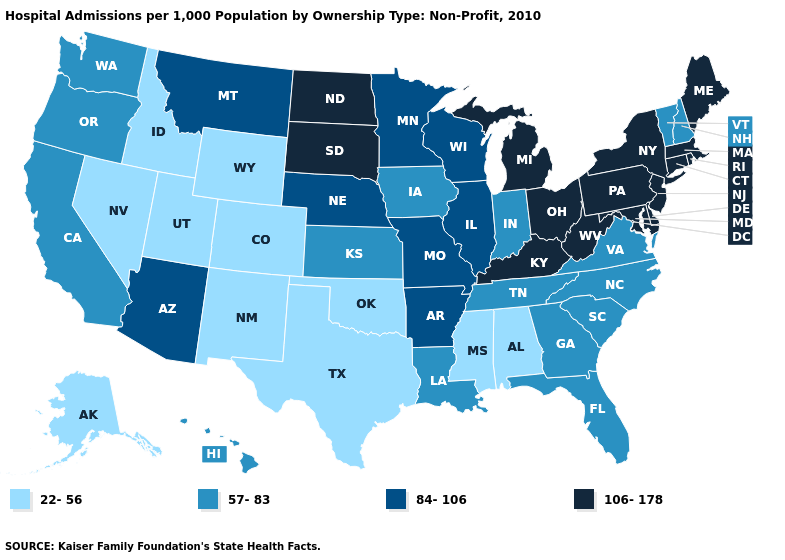Is the legend a continuous bar?
Answer briefly. No. Among the states that border Iowa , does Wisconsin have the highest value?
Give a very brief answer. No. Name the states that have a value in the range 22-56?
Keep it brief. Alabama, Alaska, Colorado, Idaho, Mississippi, Nevada, New Mexico, Oklahoma, Texas, Utah, Wyoming. Does the map have missing data?
Short answer required. No. Which states hav the highest value in the South?
Quick response, please. Delaware, Kentucky, Maryland, West Virginia. What is the highest value in the USA?
Give a very brief answer. 106-178. Among the states that border Indiana , which have the lowest value?
Answer briefly. Illinois. What is the lowest value in the South?
Concise answer only. 22-56. Name the states that have a value in the range 57-83?
Answer briefly. California, Florida, Georgia, Hawaii, Indiana, Iowa, Kansas, Louisiana, New Hampshire, North Carolina, Oregon, South Carolina, Tennessee, Vermont, Virginia, Washington. Among the states that border Oregon , which have the lowest value?
Concise answer only. Idaho, Nevada. Name the states that have a value in the range 22-56?
Answer briefly. Alabama, Alaska, Colorado, Idaho, Mississippi, Nevada, New Mexico, Oklahoma, Texas, Utah, Wyoming. What is the value of Arkansas?
Write a very short answer. 84-106. Which states have the lowest value in the West?
Quick response, please. Alaska, Colorado, Idaho, Nevada, New Mexico, Utah, Wyoming. What is the value of California?
Concise answer only. 57-83. Name the states that have a value in the range 22-56?
Give a very brief answer. Alabama, Alaska, Colorado, Idaho, Mississippi, Nevada, New Mexico, Oklahoma, Texas, Utah, Wyoming. 